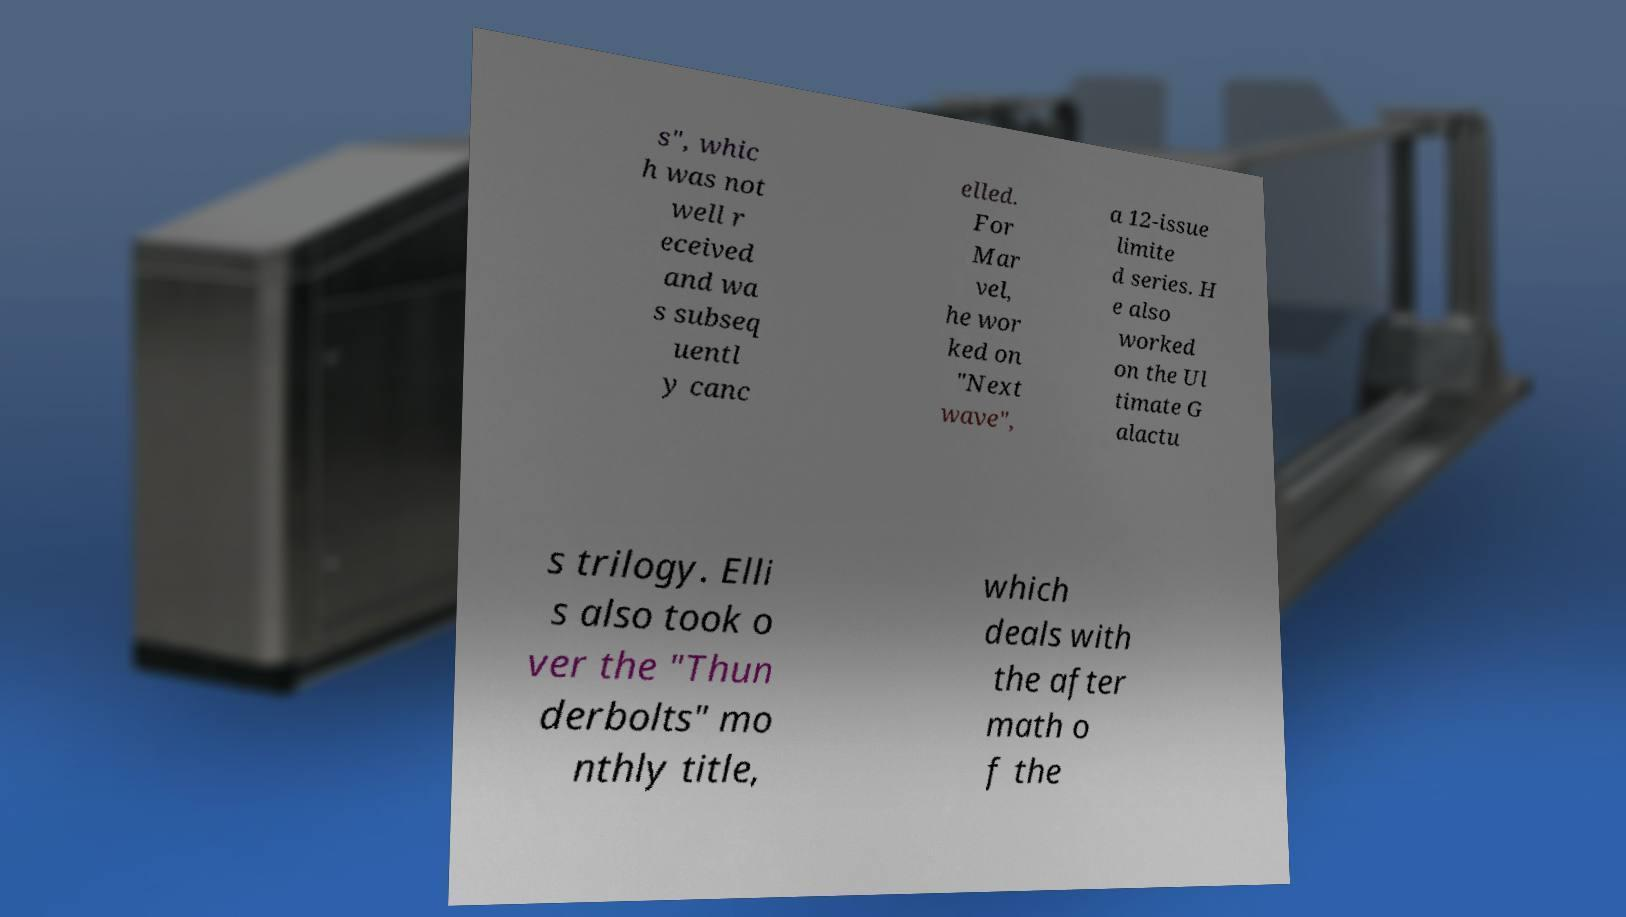Please read and relay the text visible in this image. What does it say? s", whic h was not well r eceived and wa s subseq uentl y canc elled. For Mar vel, he wor ked on "Next wave", a 12-issue limite d series. H e also worked on the Ul timate G alactu s trilogy. Elli s also took o ver the "Thun derbolts" mo nthly title, which deals with the after math o f the 